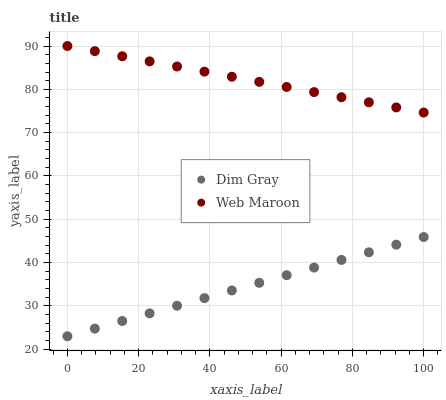Does Dim Gray have the minimum area under the curve?
Answer yes or no. Yes. Does Web Maroon have the maximum area under the curve?
Answer yes or no. Yes. Does Web Maroon have the minimum area under the curve?
Answer yes or no. No. Is Web Maroon the smoothest?
Answer yes or no. Yes. Is Dim Gray the roughest?
Answer yes or no. Yes. Is Web Maroon the roughest?
Answer yes or no. No. Does Dim Gray have the lowest value?
Answer yes or no. Yes. Does Web Maroon have the lowest value?
Answer yes or no. No. Does Web Maroon have the highest value?
Answer yes or no. Yes. Is Dim Gray less than Web Maroon?
Answer yes or no. Yes. Is Web Maroon greater than Dim Gray?
Answer yes or no. Yes. Does Dim Gray intersect Web Maroon?
Answer yes or no. No. 